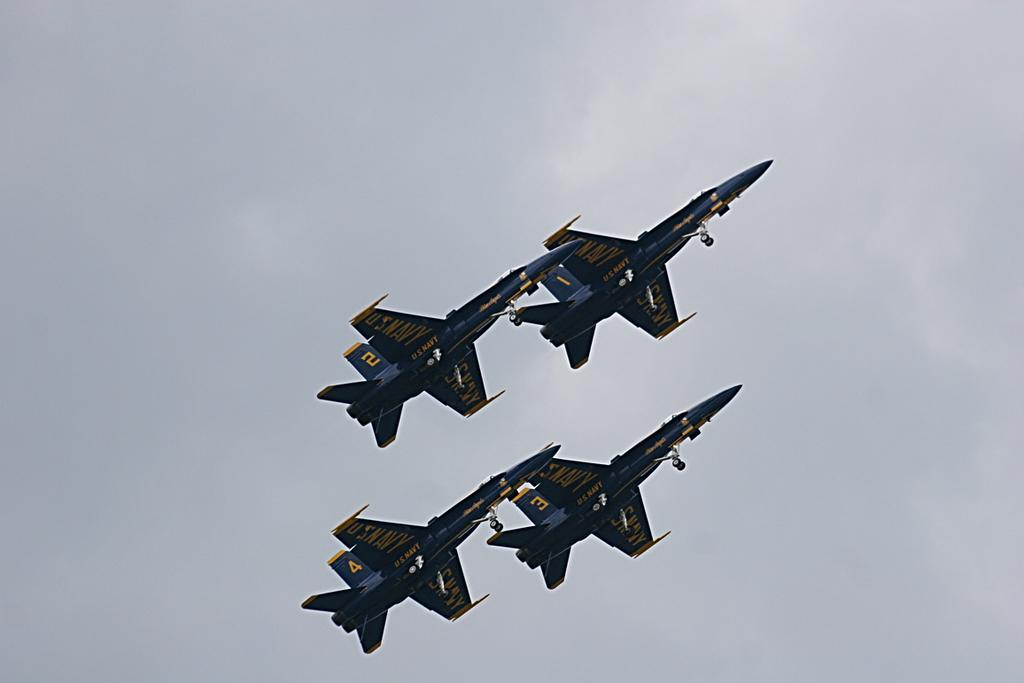How many aeroplanes are visible in the image? There are four aeroplanes in the image. What are the aeroplanes doing in the image? The aeroplanes are flying in the sky. What color are the aeroplanes? The aeroplanes are blue in color. How many sisters are sitting on the street in the image? There are no sisters or streets present in the image; it features four blue aeroplanes flying in the sky. 